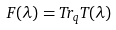Convert formula to latex. <formula><loc_0><loc_0><loc_500><loc_500>F ( \lambda ) = T r _ { q } T ( \lambda )</formula> 